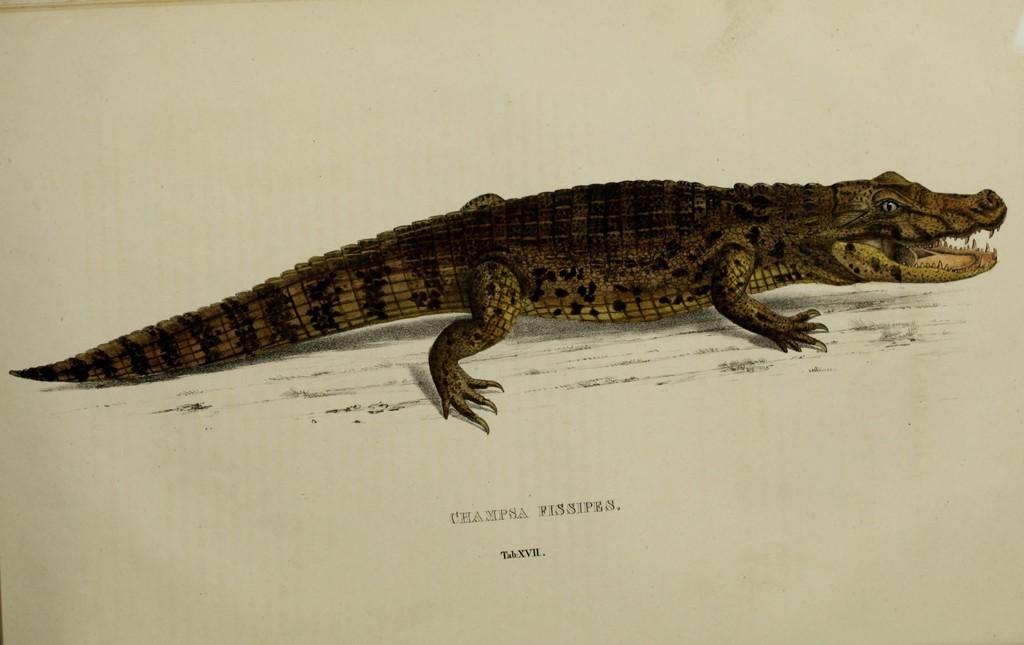What is depicted in the image? There is a sketch of a crocodile in the image. Is there any text associated with the sketch? Yes, there is some text beneath the sketch of the crocodile. How many beetles can be seen crawling on the grain in the image? There are no beetles or grain present in the image; it features a sketch of a crocodile with text beneath it. 